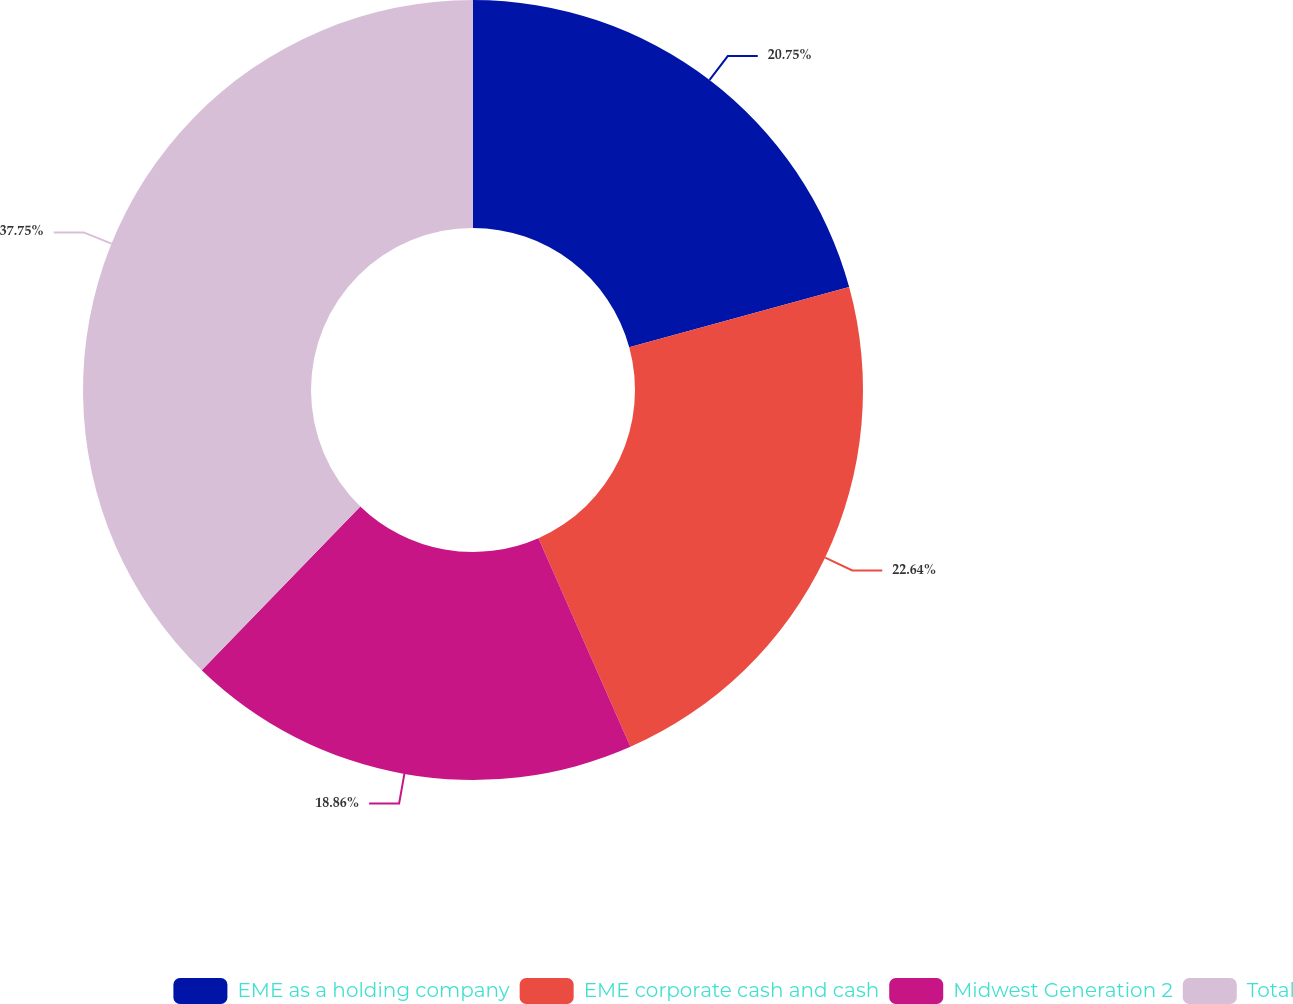Convert chart. <chart><loc_0><loc_0><loc_500><loc_500><pie_chart><fcel>EME as a holding company<fcel>EME corporate cash and cash<fcel>Midwest Generation 2<fcel>Total<nl><fcel>20.75%<fcel>22.64%<fcel>18.86%<fcel>37.76%<nl></chart> 